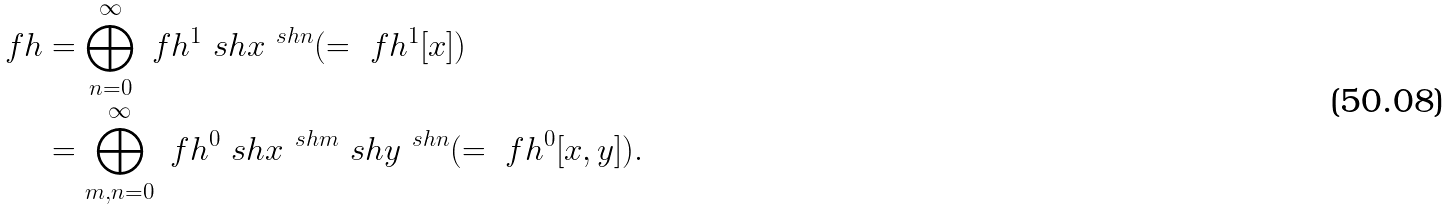Convert formula to latex. <formula><loc_0><loc_0><loc_500><loc_500>\ f h & = \bigoplus _ { n = 0 } ^ { \infty } \ f h ^ { 1 } \ s h x ^ { \ s h n } ( = \ f h ^ { 1 } [ x ] ) \\ & = \bigoplus _ { m , n = 0 } ^ { \infty } \ f h ^ { 0 } \ s h x ^ { \ s h m } \ s h y ^ { \ s h n } ( = \ f h ^ { 0 } [ x , y ] ) .</formula> 